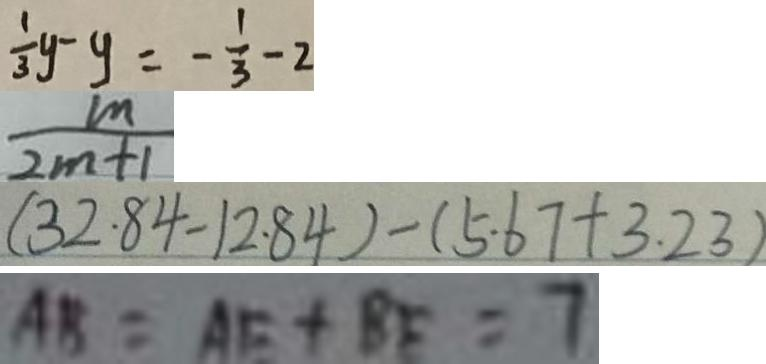Convert formula to latex. <formula><loc_0><loc_0><loc_500><loc_500>\frac { 1 } { 3 } y - y = - \frac { 1 } { 3 } - 2 
 \frac { m } { 2 m + 1 } 
 ( 3 2 . 8 4 - 1 2 . 8 4 ) - ( 5 . 6 7 + 3 . 2 3 ) 
 A B = A E + B E = 7</formula> 